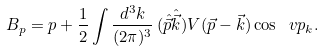Convert formula to latex. <formula><loc_0><loc_0><loc_500><loc_500>B _ { p } = p + \frac { 1 } { 2 } \int \frac { d ^ { 3 } k } { ( 2 \pi ) ^ { 3 } } \, ( \hat { \vec { p } } \hat { \vec { k } } ) V ( \vec { p } - \vec { k } ) \cos \ v p _ { k } .</formula> 